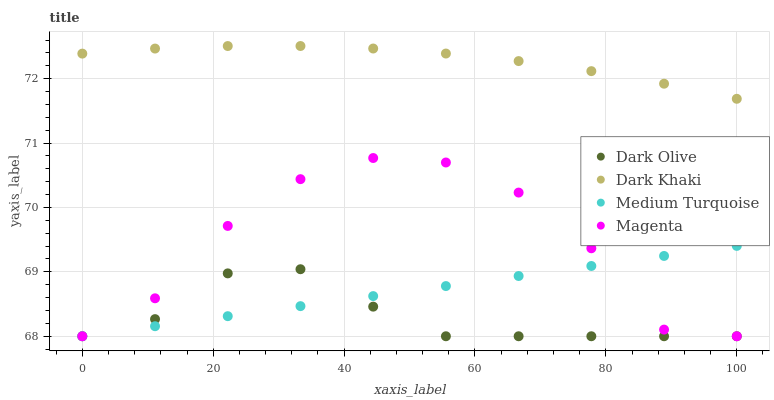Does Dark Olive have the minimum area under the curve?
Answer yes or no. Yes. Does Dark Khaki have the maximum area under the curve?
Answer yes or no. Yes. Does Magenta have the minimum area under the curve?
Answer yes or no. No. Does Magenta have the maximum area under the curve?
Answer yes or no. No. Is Medium Turquoise the smoothest?
Answer yes or no. Yes. Is Magenta the roughest?
Answer yes or no. Yes. Is Dark Olive the smoothest?
Answer yes or no. No. Is Dark Olive the roughest?
Answer yes or no. No. Does Magenta have the lowest value?
Answer yes or no. Yes. Does Dark Khaki have the highest value?
Answer yes or no. Yes. Does Magenta have the highest value?
Answer yes or no. No. Is Medium Turquoise less than Dark Khaki?
Answer yes or no. Yes. Is Dark Khaki greater than Medium Turquoise?
Answer yes or no. Yes. Does Magenta intersect Dark Olive?
Answer yes or no. Yes. Is Magenta less than Dark Olive?
Answer yes or no. No. Is Magenta greater than Dark Olive?
Answer yes or no. No. Does Medium Turquoise intersect Dark Khaki?
Answer yes or no. No. 